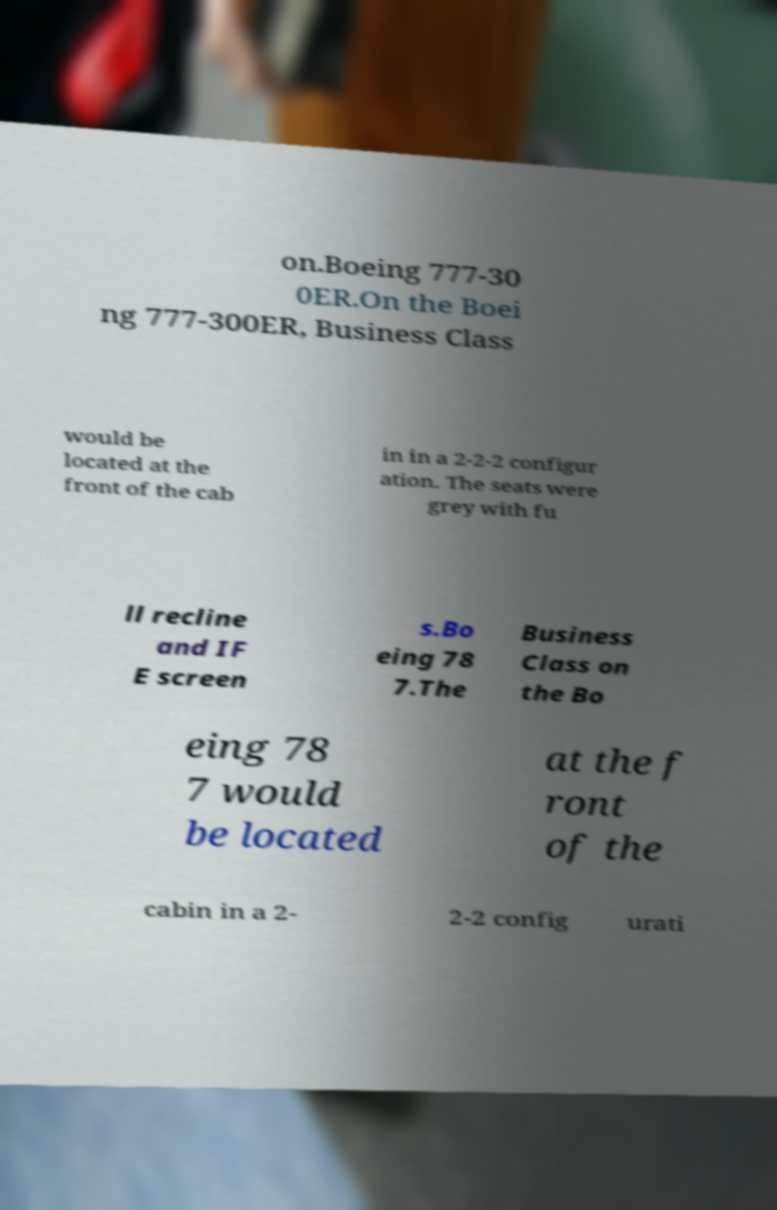What messages or text are displayed in this image? I need them in a readable, typed format. on.Boeing 777-30 0ER.On the Boei ng 777-300ER, Business Class would be located at the front of the cab in in a 2-2-2 configur ation. The seats were grey with fu ll recline and IF E screen s.Bo eing 78 7.The Business Class on the Bo eing 78 7 would be located at the f ront of the cabin in a 2- 2-2 config urati 